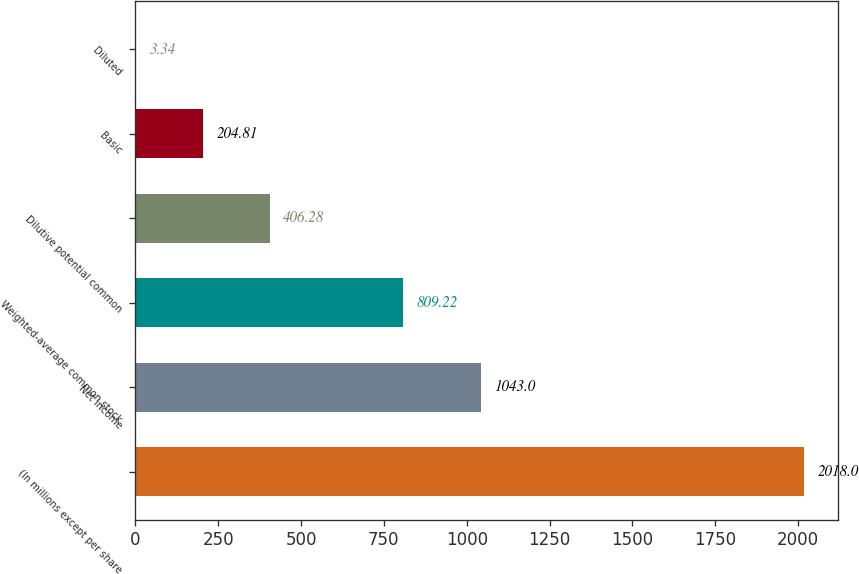Convert chart. <chart><loc_0><loc_0><loc_500><loc_500><bar_chart><fcel>(In millions except per share<fcel>Net income<fcel>Weighted-average common stock<fcel>Dilutive potential common<fcel>Basic<fcel>Diluted<nl><fcel>2018<fcel>1043<fcel>809.22<fcel>406.28<fcel>204.81<fcel>3.34<nl></chart> 